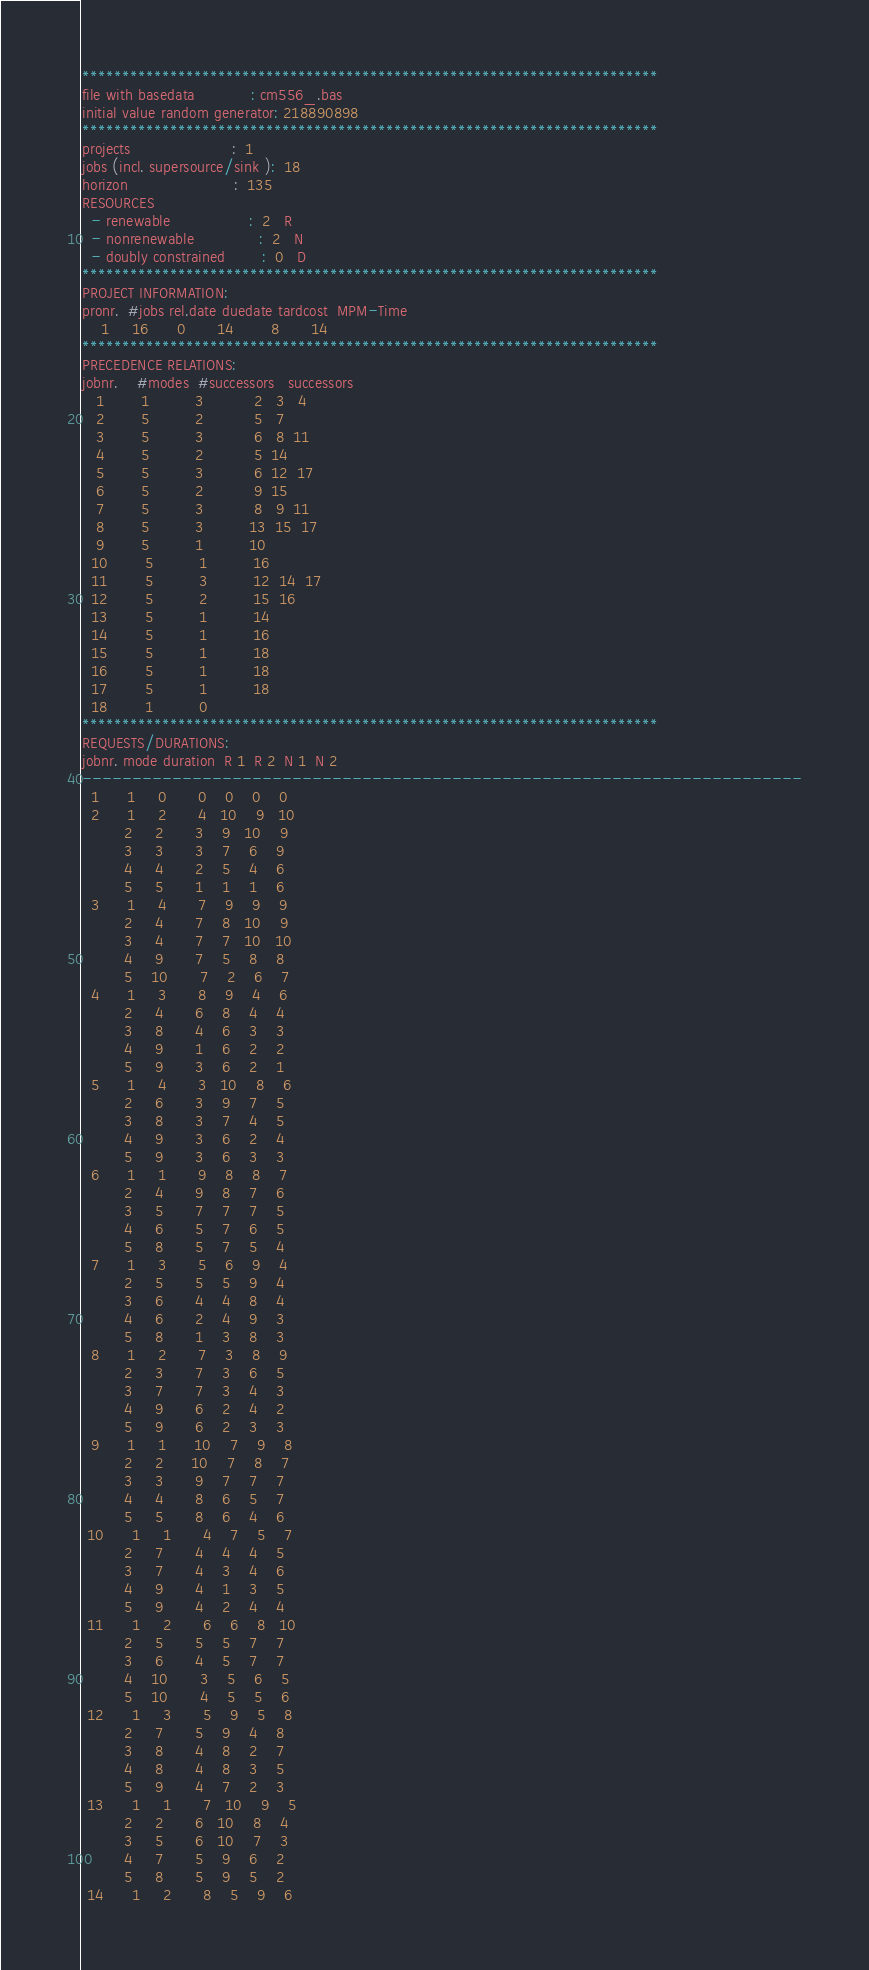<code> <loc_0><loc_0><loc_500><loc_500><_ObjectiveC_>************************************************************************
file with basedata            : cm556_.bas
initial value random generator: 218890898
************************************************************************
projects                      :  1
jobs (incl. supersource/sink ):  18
horizon                       :  135
RESOURCES
  - renewable                 :  2   R
  - nonrenewable              :  2   N
  - doubly constrained        :  0   D
************************************************************************
PROJECT INFORMATION:
pronr.  #jobs rel.date duedate tardcost  MPM-Time
    1     16      0       14        8       14
************************************************************************
PRECEDENCE RELATIONS:
jobnr.    #modes  #successors   successors
   1        1          3           2   3   4
   2        5          2           5   7
   3        5          3           6   8  11
   4        5          2           5  14
   5        5          3           6  12  17
   6        5          2           9  15
   7        5          3           8   9  11
   8        5          3          13  15  17
   9        5          1          10
  10        5          1          16
  11        5          3          12  14  17
  12        5          2          15  16
  13        5          1          14
  14        5          1          16
  15        5          1          18
  16        5          1          18
  17        5          1          18
  18        1          0        
************************************************************************
REQUESTS/DURATIONS:
jobnr. mode duration  R 1  R 2  N 1  N 2
------------------------------------------------------------------------
  1      1     0       0    0    0    0
  2      1     2       4   10    9   10
         2     2       3    9   10    9
         3     3       3    7    6    9
         4     4       2    5    4    6
         5     5       1    1    1    6
  3      1     4       7    9    9    9
         2     4       7    8   10    9
         3     4       7    7   10   10
         4     9       7    5    8    8
         5    10       7    2    6    7
  4      1     3       8    9    4    6
         2     4       6    8    4    4
         3     8       4    6    3    3
         4     9       1    6    2    2
         5     9       3    6    2    1
  5      1     4       3   10    8    6
         2     6       3    9    7    5
         3     8       3    7    4    5
         4     9       3    6    2    4
         5     9       3    6    3    3
  6      1     1       9    8    8    7
         2     4       9    8    7    6
         3     5       7    7    7    5
         4     6       5    7    6    5
         5     8       5    7    5    4
  7      1     3       5    6    9    4
         2     5       5    5    9    4
         3     6       4    4    8    4
         4     6       2    4    9    3
         5     8       1    3    8    3
  8      1     2       7    3    8    9
         2     3       7    3    6    5
         3     7       7    3    4    3
         4     9       6    2    4    2
         5     9       6    2    3    3
  9      1     1      10    7    9    8
         2     2      10    7    8    7
         3     3       9    7    7    7
         4     4       8    6    5    7
         5     5       8    6    4    6
 10      1     1       4    7    5    7
         2     7       4    4    4    5
         3     7       4    3    4    6
         4     9       4    1    3    5
         5     9       4    2    4    4
 11      1     2       6    6    8   10
         2     5       5    5    7    7
         3     6       4    5    7    7
         4    10       3    5    6    5
         5    10       4    5    5    6
 12      1     3       5    9    5    8
         2     7       5    9    4    8
         3     8       4    8    2    7
         4     8       4    8    3    5
         5     9       4    7    2    3
 13      1     1       7   10    9    5
         2     2       6   10    8    4
         3     5       6   10    7    3
         4     7       5    9    6    2
         5     8       5    9    5    2
 14      1     2       8    5    9    6</code> 